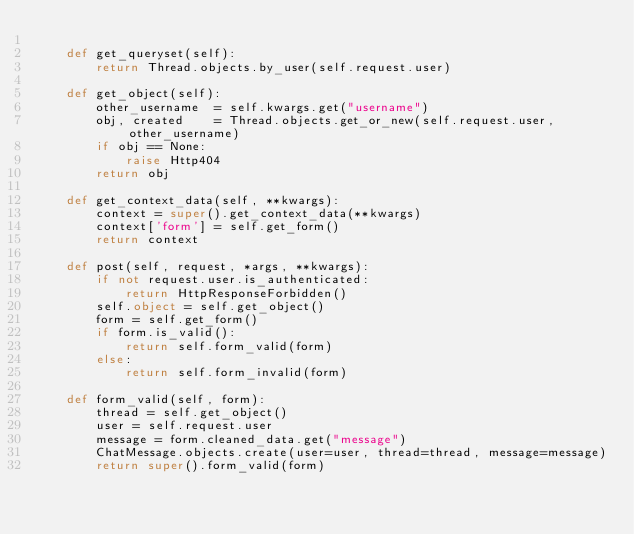<code> <loc_0><loc_0><loc_500><loc_500><_Python_>
    def get_queryset(self):
        return Thread.objects.by_user(self.request.user)

    def get_object(self):
        other_username  = self.kwargs.get("username")
        obj, created    = Thread.objects.get_or_new(self.request.user, other_username)
        if obj == None:
            raise Http404
        return obj

    def get_context_data(self, **kwargs):
        context = super().get_context_data(**kwargs)
        context['form'] = self.get_form()
        return context

    def post(self, request, *args, **kwargs):
        if not request.user.is_authenticated:
            return HttpResponseForbidden()
        self.object = self.get_object()
        form = self.get_form()
        if form.is_valid():
            return self.form_valid(form)
        else:
            return self.form_invalid(form)

    def form_valid(self, form):
        thread = self.get_object()
        user = self.request.user
        message = form.cleaned_data.get("message")
        ChatMessage.objects.create(user=user, thread=thread, message=message)
        return super().form_valid(form)


</code> 